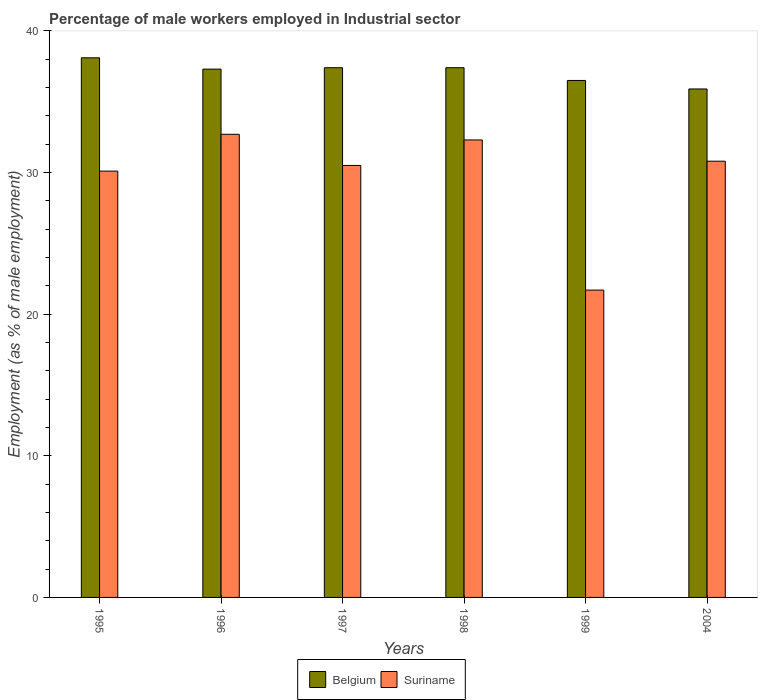How many different coloured bars are there?
Provide a short and direct response. 2. How many groups of bars are there?
Give a very brief answer. 6. Are the number of bars per tick equal to the number of legend labels?
Ensure brevity in your answer.  Yes. Are the number of bars on each tick of the X-axis equal?
Offer a very short reply. Yes. How many bars are there on the 5th tick from the left?
Provide a short and direct response. 2. How many bars are there on the 5th tick from the right?
Your answer should be compact. 2. What is the label of the 6th group of bars from the left?
Your answer should be compact. 2004. What is the percentage of male workers employed in Industrial sector in Suriname in 1995?
Your response must be concise. 30.1. Across all years, what is the maximum percentage of male workers employed in Industrial sector in Suriname?
Ensure brevity in your answer.  32.7. Across all years, what is the minimum percentage of male workers employed in Industrial sector in Belgium?
Give a very brief answer. 35.9. What is the total percentage of male workers employed in Industrial sector in Suriname in the graph?
Keep it short and to the point. 178.1. What is the difference between the percentage of male workers employed in Industrial sector in Belgium in 1997 and that in 1999?
Give a very brief answer. 0.9. What is the difference between the percentage of male workers employed in Industrial sector in Belgium in 1997 and the percentage of male workers employed in Industrial sector in Suriname in 1998?
Offer a very short reply. 5.1. What is the average percentage of male workers employed in Industrial sector in Belgium per year?
Your answer should be very brief. 37.1. In the year 1998, what is the difference between the percentage of male workers employed in Industrial sector in Suriname and percentage of male workers employed in Industrial sector in Belgium?
Your answer should be very brief. -5.1. In how many years, is the percentage of male workers employed in Industrial sector in Suriname greater than 10 %?
Your answer should be compact. 6. What is the ratio of the percentage of male workers employed in Industrial sector in Belgium in 1996 to that in 1998?
Make the answer very short. 1. Is the percentage of male workers employed in Industrial sector in Suriname in 1998 less than that in 1999?
Offer a very short reply. No. What is the difference between the highest and the second highest percentage of male workers employed in Industrial sector in Suriname?
Ensure brevity in your answer.  0.4. What is the difference between the highest and the lowest percentage of male workers employed in Industrial sector in Belgium?
Keep it short and to the point. 2.2. In how many years, is the percentage of male workers employed in Industrial sector in Belgium greater than the average percentage of male workers employed in Industrial sector in Belgium taken over all years?
Provide a short and direct response. 4. Is the sum of the percentage of male workers employed in Industrial sector in Belgium in 1996 and 1998 greater than the maximum percentage of male workers employed in Industrial sector in Suriname across all years?
Make the answer very short. Yes. What does the 2nd bar from the left in 1997 represents?
Make the answer very short. Suriname. What does the 1st bar from the right in 1996 represents?
Give a very brief answer. Suriname. Are all the bars in the graph horizontal?
Provide a succinct answer. No. How many years are there in the graph?
Offer a very short reply. 6. What is the difference between two consecutive major ticks on the Y-axis?
Provide a short and direct response. 10. Does the graph contain any zero values?
Your response must be concise. No. How are the legend labels stacked?
Offer a terse response. Horizontal. What is the title of the graph?
Give a very brief answer. Percentage of male workers employed in Industrial sector. Does "Slovak Republic" appear as one of the legend labels in the graph?
Give a very brief answer. No. What is the label or title of the Y-axis?
Your answer should be compact. Employment (as % of male employment). What is the Employment (as % of male employment) of Belgium in 1995?
Make the answer very short. 38.1. What is the Employment (as % of male employment) of Suriname in 1995?
Provide a short and direct response. 30.1. What is the Employment (as % of male employment) in Belgium in 1996?
Your answer should be very brief. 37.3. What is the Employment (as % of male employment) of Suriname in 1996?
Provide a succinct answer. 32.7. What is the Employment (as % of male employment) in Belgium in 1997?
Your answer should be compact. 37.4. What is the Employment (as % of male employment) in Suriname in 1997?
Your answer should be compact. 30.5. What is the Employment (as % of male employment) in Belgium in 1998?
Make the answer very short. 37.4. What is the Employment (as % of male employment) of Suriname in 1998?
Make the answer very short. 32.3. What is the Employment (as % of male employment) of Belgium in 1999?
Your answer should be compact. 36.5. What is the Employment (as % of male employment) in Suriname in 1999?
Keep it short and to the point. 21.7. What is the Employment (as % of male employment) of Belgium in 2004?
Your answer should be very brief. 35.9. What is the Employment (as % of male employment) in Suriname in 2004?
Your answer should be compact. 30.8. Across all years, what is the maximum Employment (as % of male employment) in Belgium?
Your answer should be very brief. 38.1. Across all years, what is the maximum Employment (as % of male employment) in Suriname?
Give a very brief answer. 32.7. Across all years, what is the minimum Employment (as % of male employment) in Belgium?
Provide a succinct answer. 35.9. Across all years, what is the minimum Employment (as % of male employment) of Suriname?
Provide a succinct answer. 21.7. What is the total Employment (as % of male employment) in Belgium in the graph?
Offer a terse response. 222.6. What is the total Employment (as % of male employment) of Suriname in the graph?
Offer a very short reply. 178.1. What is the difference between the Employment (as % of male employment) in Suriname in 1995 and that in 1997?
Offer a very short reply. -0.4. What is the difference between the Employment (as % of male employment) in Belgium in 1995 and that in 1999?
Provide a short and direct response. 1.6. What is the difference between the Employment (as % of male employment) of Suriname in 1995 and that in 1999?
Offer a very short reply. 8.4. What is the difference between the Employment (as % of male employment) in Belgium in 1995 and that in 2004?
Ensure brevity in your answer.  2.2. What is the difference between the Employment (as % of male employment) of Suriname in 1995 and that in 2004?
Give a very brief answer. -0.7. What is the difference between the Employment (as % of male employment) in Belgium in 1996 and that in 1999?
Provide a short and direct response. 0.8. What is the difference between the Employment (as % of male employment) in Suriname in 1996 and that in 1999?
Offer a terse response. 11. What is the difference between the Employment (as % of male employment) in Suriname in 1996 and that in 2004?
Keep it short and to the point. 1.9. What is the difference between the Employment (as % of male employment) in Belgium in 1997 and that in 1998?
Your answer should be compact. 0. What is the difference between the Employment (as % of male employment) of Suriname in 1997 and that in 1999?
Offer a terse response. 8.8. What is the difference between the Employment (as % of male employment) in Suriname in 1997 and that in 2004?
Your answer should be very brief. -0.3. What is the difference between the Employment (as % of male employment) in Belgium in 1998 and that in 2004?
Your response must be concise. 1.5. What is the difference between the Employment (as % of male employment) in Suriname in 1999 and that in 2004?
Give a very brief answer. -9.1. What is the difference between the Employment (as % of male employment) of Belgium in 1995 and the Employment (as % of male employment) of Suriname in 1996?
Your response must be concise. 5.4. What is the difference between the Employment (as % of male employment) of Belgium in 1995 and the Employment (as % of male employment) of Suriname in 1997?
Offer a very short reply. 7.6. What is the difference between the Employment (as % of male employment) of Belgium in 1996 and the Employment (as % of male employment) of Suriname in 1997?
Give a very brief answer. 6.8. What is the difference between the Employment (as % of male employment) of Belgium in 1996 and the Employment (as % of male employment) of Suriname in 1998?
Your answer should be very brief. 5. What is the difference between the Employment (as % of male employment) in Belgium in 1996 and the Employment (as % of male employment) in Suriname in 2004?
Your answer should be very brief. 6.5. What is the difference between the Employment (as % of male employment) of Belgium in 1997 and the Employment (as % of male employment) of Suriname in 1999?
Your answer should be compact. 15.7. What is the difference between the Employment (as % of male employment) in Belgium in 1997 and the Employment (as % of male employment) in Suriname in 2004?
Keep it short and to the point. 6.6. What is the difference between the Employment (as % of male employment) in Belgium in 1999 and the Employment (as % of male employment) in Suriname in 2004?
Make the answer very short. 5.7. What is the average Employment (as % of male employment) in Belgium per year?
Your answer should be very brief. 37.1. What is the average Employment (as % of male employment) in Suriname per year?
Keep it short and to the point. 29.68. In the year 1996, what is the difference between the Employment (as % of male employment) of Belgium and Employment (as % of male employment) of Suriname?
Your answer should be very brief. 4.6. In the year 1997, what is the difference between the Employment (as % of male employment) in Belgium and Employment (as % of male employment) in Suriname?
Ensure brevity in your answer.  6.9. In the year 1999, what is the difference between the Employment (as % of male employment) of Belgium and Employment (as % of male employment) of Suriname?
Ensure brevity in your answer.  14.8. In the year 2004, what is the difference between the Employment (as % of male employment) of Belgium and Employment (as % of male employment) of Suriname?
Your answer should be very brief. 5.1. What is the ratio of the Employment (as % of male employment) of Belgium in 1995 to that in 1996?
Provide a succinct answer. 1.02. What is the ratio of the Employment (as % of male employment) in Suriname in 1995 to that in 1996?
Offer a very short reply. 0.92. What is the ratio of the Employment (as % of male employment) of Belgium in 1995 to that in 1997?
Provide a short and direct response. 1.02. What is the ratio of the Employment (as % of male employment) of Suriname in 1995 to that in 1997?
Your answer should be very brief. 0.99. What is the ratio of the Employment (as % of male employment) in Belgium in 1995 to that in 1998?
Offer a very short reply. 1.02. What is the ratio of the Employment (as % of male employment) in Suriname in 1995 to that in 1998?
Your answer should be compact. 0.93. What is the ratio of the Employment (as % of male employment) in Belgium in 1995 to that in 1999?
Keep it short and to the point. 1.04. What is the ratio of the Employment (as % of male employment) in Suriname in 1995 to that in 1999?
Provide a succinct answer. 1.39. What is the ratio of the Employment (as % of male employment) of Belgium in 1995 to that in 2004?
Make the answer very short. 1.06. What is the ratio of the Employment (as % of male employment) of Suriname in 1995 to that in 2004?
Your response must be concise. 0.98. What is the ratio of the Employment (as % of male employment) of Belgium in 1996 to that in 1997?
Keep it short and to the point. 1. What is the ratio of the Employment (as % of male employment) of Suriname in 1996 to that in 1997?
Keep it short and to the point. 1.07. What is the ratio of the Employment (as % of male employment) in Suriname in 1996 to that in 1998?
Make the answer very short. 1.01. What is the ratio of the Employment (as % of male employment) in Belgium in 1996 to that in 1999?
Your answer should be compact. 1.02. What is the ratio of the Employment (as % of male employment) in Suriname in 1996 to that in 1999?
Your answer should be very brief. 1.51. What is the ratio of the Employment (as % of male employment) of Belgium in 1996 to that in 2004?
Give a very brief answer. 1.04. What is the ratio of the Employment (as % of male employment) of Suriname in 1996 to that in 2004?
Keep it short and to the point. 1.06. What is the ratio of the Employment (as % of male employment) of Suriname in 1997 to that in 1998?
Give a very brief answer. 0.94. What is the ratio of the Employment (as % of male employment) of Belgium in 1997 to that in 1999?
Your response must be concise. 1.02. What is the ratio of the Employment (as % of male employment) of Suriname in 1997 to that in 1999?
Keep it short and to the point. 1.41. What is the ratio of the Employment (as % of male employment) of Belgium in 1997 to that in 2004?
Your response must be concise. 1.04. What is the ratio of the Employment (as % of male employment) in Suriname in 1997 to that in 2004?
Provide a succinct answer. 0.99. What is the ratio of the Employment (as % of male employment) of Belgium in 1998 to that in 1999?
Your response must be concise. 1.02. What is the ratio of the Employment (as % of male employment) of Suriname in 1998 to that in 1999?
Keep it short and to the point. 1.49. What is the ratio of the Employment (as % of male employment) in Belgium in 1998 to that in 2004?
Make the answer very short. 1.04. What is the ratio of the Employment (as % of male employment) of Suriname in 1998 to that in 2004?
Keep it short and to the point. 1.05. What is the ratio of the Employment (as % of male employment) in Belgium in 1999 to that in 2004?
Your response must be concise. 1.02. What is the ratio of the Employment (as % of male employment) in Suriname in 1999 to that in 2004?
Offer a terse response. 0.7. What is the difference between the highest and the second highest Employment (as % of male employment) of Belgium?
Offer a very short reply. 0.7. What is the difference between the highest and the second highest Employment (as % of male employment) of Suriname?
Make the answer very short. 0.4. 